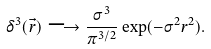Convert formula to latex. <formula><loc_0><loc_0><loc_500><loc_500>\delta ^ { 3 } ( \vec { r } ) \longrightarrow \frac { \sigma ^ { 3 } } { \pi ^ { 3 / 2 } } \exp ( - \sigma ^ { 2 } r ^ { 2 } ) .</formula> 